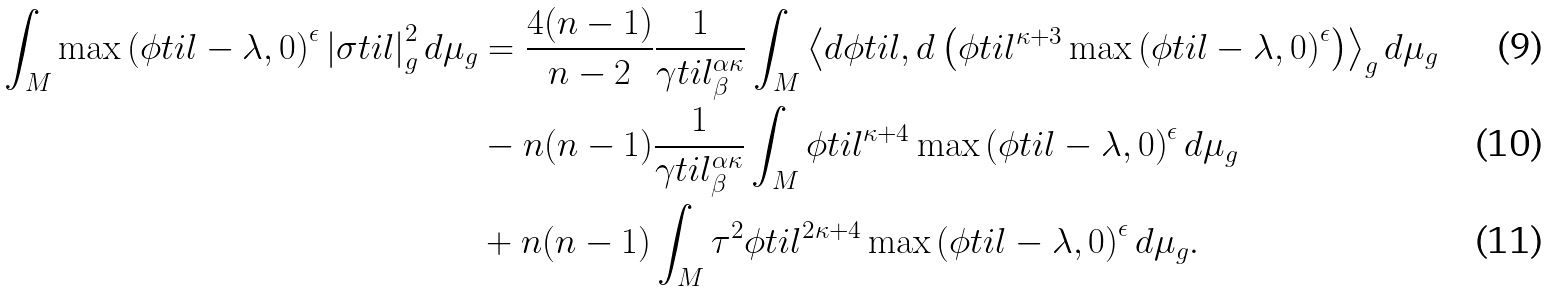Convert formula to latex. <formula><loc_0><loc_0><loc_500><loc_500>\int _ { M } \max \left ( \phi t i l - \lambda , 0 \right ) ^ { \epsilon } \left | \sigma t i l \right | _ { g } ^ { 2 } d \mu _ { g } & = \frac { 4 ( n - 1 ) } { n - 2 } \frac { 1 } { \gamma t i l _ { \beta } ^ { \alpha \kappa } } \int _ { M } \left \langle d \phi t i l , d \left ( \phi t i l ^ { \kappa + 3 } \max \left ( \phi t i l - \lambda , 0 \right ) ^ { \epsilon } \right ) \right \rangle _ { g } d \mu _ { g } \\ & - n ( n - 1 ) \frac { 1 } { \gamma t i l _ { \beta } ^ { \alpha \kappa } } \int _ { M } \phi t i l ^ { \kappa + 4 } \max \left ( \phi t i l - \lambda , 0 \right ) ^ { \epsilon } d \mu _ { g } \\ & + n ( n - 1 ) \int _ { M } \tau ^ { 2 } \phi t i l ^ { 2 \kappa + 4 } \max \left ( \phi t i l - \lambda , 0 \right ) ^ { \epsilon } d \mu _ { g } .</formula> 